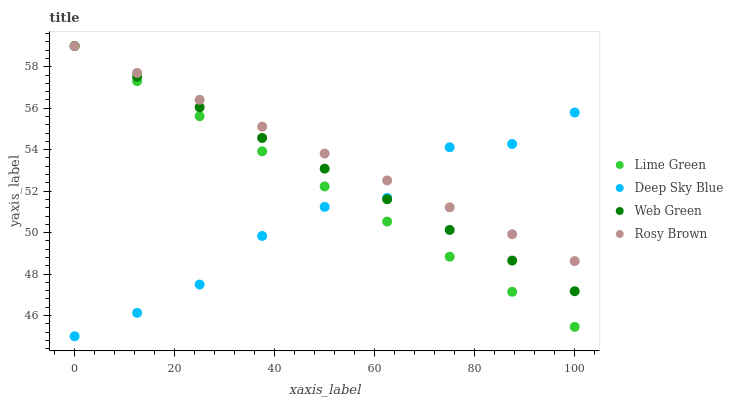Does Deep Sky Blue have the minimum area under the curve?
Answer yes or no. Yes. Does Rosy Brown have the maximum area under the curve?
Answer yes or no. Yes. Does Lime Green have the minimum area under the curve?
Answer yes or no. No. Does Lime Green have the maximum area under the curve?
Answer yes or no. No. Is Web Green the smoothest?
Answer yes or no. Yes. Is Deep Sky Blue the roughest?
Answer yes or no. Yes. Is Lime Green the smoothest?
Answer yes or no. No. Is Lime Green the roughest?
Answer yes or no. No. Does Deep Sky Blue have the lowest value?
Answer yes or no. Yes. Does Lime Green have the lowest value?
Answer yes or no. No. Does Web Green have the highest value?
Answer yes or no. Yes. Does Deep Sky Blue have the highest value?
Answer yes or no. No. Does Rosy Brown intersect Lime Green?
Answer yes or no. Yes. Is Rosy Brown less than Lime Green?
Answer yes or no. No. Is Rosy Brown greater than Lime Green?
Answer yes or no. No. 